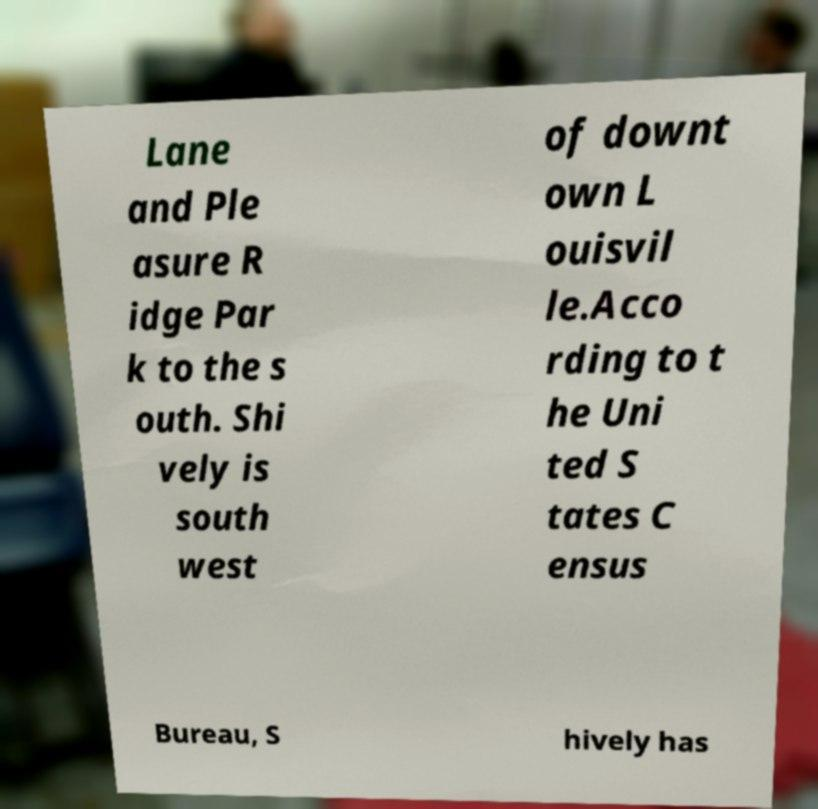Could you extract and type out the text from this image? Lane and Ple asure R idge Par k to the s outh. Shi vely is south west of downt own L ouisvil le.Acco rding to t he Uni ted S tates C ensus Bureau, S hively has 